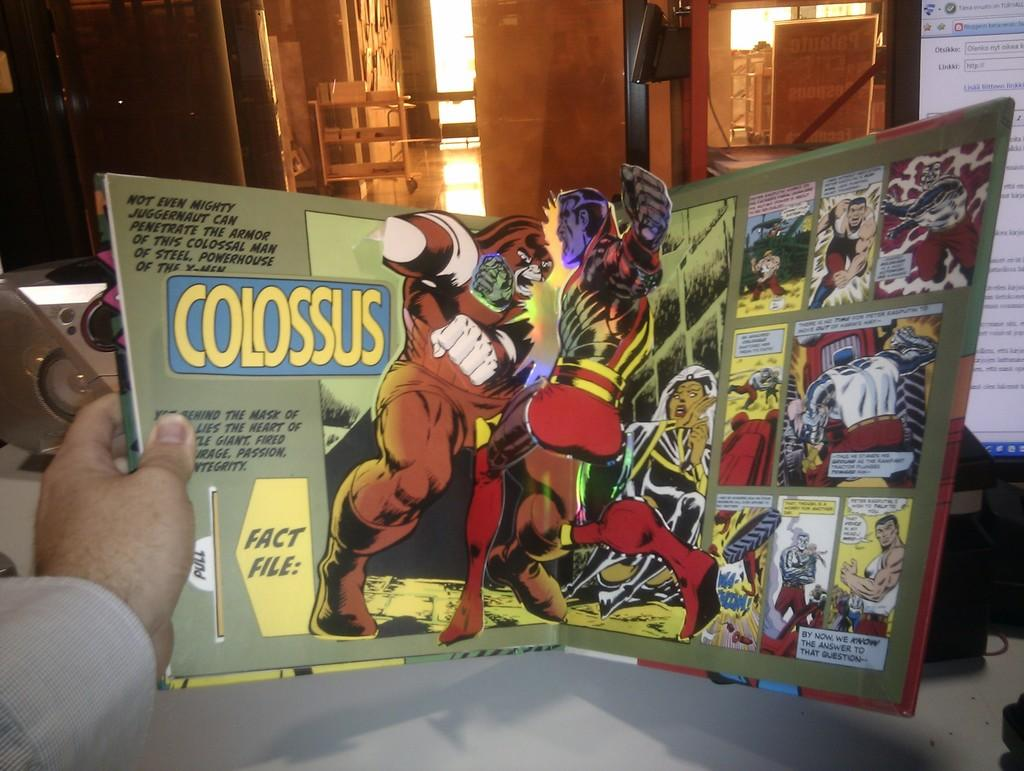<image>
Write a terse but informative summary of the picture. A comic book with popup art, the name Colossus is printed on the lefthand side. 